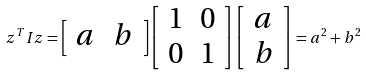Convert formula to latex. <formula><loc_0><loc_0><loc_500><loc_500>z ^ { T } I z = { \left [ \begin{array} { l l } { a } & { b } \end{array} \right ] } { \left [ \begin{array} { l l } { 1 } & { 0 } \\ { 0 } & { 1 } \end{array} \right ] } { \left [ \begin{array} { l } { a } \\ { b } \end{array} \right ] } = a ^ { 2 } + b ^ { 2 }</formula> 